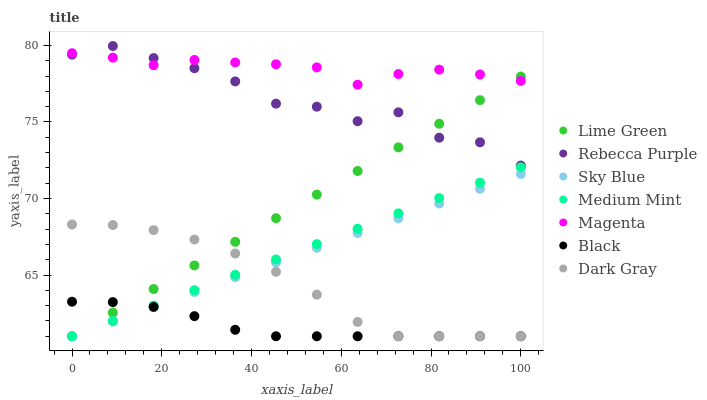Does Black have the minimum area under the curve?
Answer yes or no. Yes. Does Magenta have the maximum area under the curve?
Answer yes or no. Yes. Does Dark Gray have the minimum area under the curve?
Answer yes or no. No. Does Dark Gray have the maximum area under the curve?
Answer yes or no. No. Is Sky Blue the smoothest?
Answer yes or no. Yes. Is Rebecca Purple the roughest?
Answer yes or no. Yes. Is Dark Gray the smoothest?
Answer yes or no. No. Is Dark Gray the roughest?
Answer yes or no. No. Does Medium Mint have the lowest value?
Answer yes or no. Yes. Does Rebecca Purple have the lowest value?
Answer yes or no. No. Does Rebecca Purple have the highest value?
Answer yes or no. Yes. Does Dark Gray have the highest value?
Answer yes or no. No. Is Black less than Magenta?
Answer yes or no. Yes. Is Rebecca Purple greater than Medium Mint?
Answer yes or no. Yes. Does Black intersect Sky Blue?
Answer yes or no. Yes. Is Black less than Sky Blue?
Answer yes or no. No. Is Black greater than Sky Blue?
Answer yes or no. No. Does Black intersect Magenta?
Answer yes or no. No. 